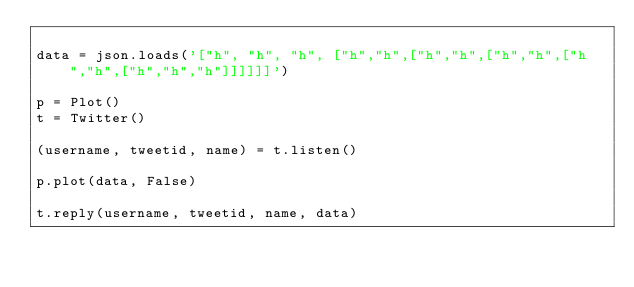Convert code to text. <code><loc_0><loc_0><loc_500><loc_500><_Python_>
data = json.loads('["h", "h", "h", ["h","h",["h","h",["h","h",["h","h",["h","h","h"]]]]]]')

p = Plot()
t = Twitter()

(username, tweetid, name) = t.listen()

p.plot(data, False)

t.reply(username, tweetid, name, data)
</code> 